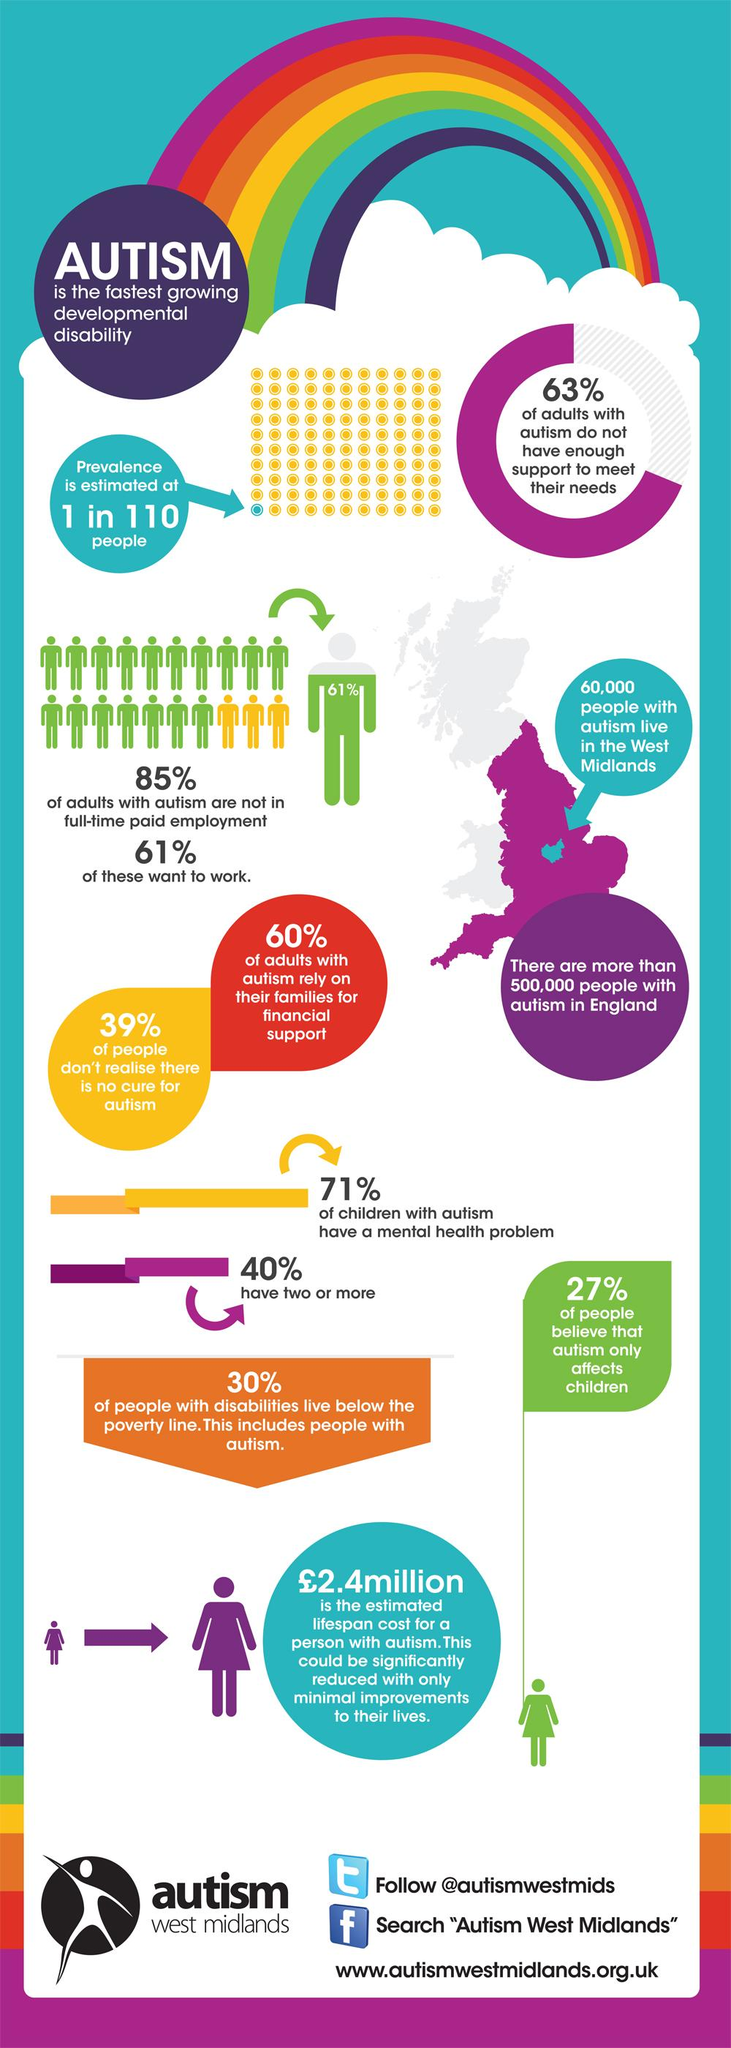Indicate a few pertinent items in this graphic. A recent study found that 27% of people believe that autism only affects children in England. In the West Midlands, 40% of adults with autism do not rely on their families for financial support. According to a recent study, approximately 37% of adults with autism in the West Midlands have the necessary support to meet their needs. A recent survey in England revealed that 61% of people are aware that there is no cure for autism. In England, it is estimated that 85% of adults with autism are not in full-time payment. 